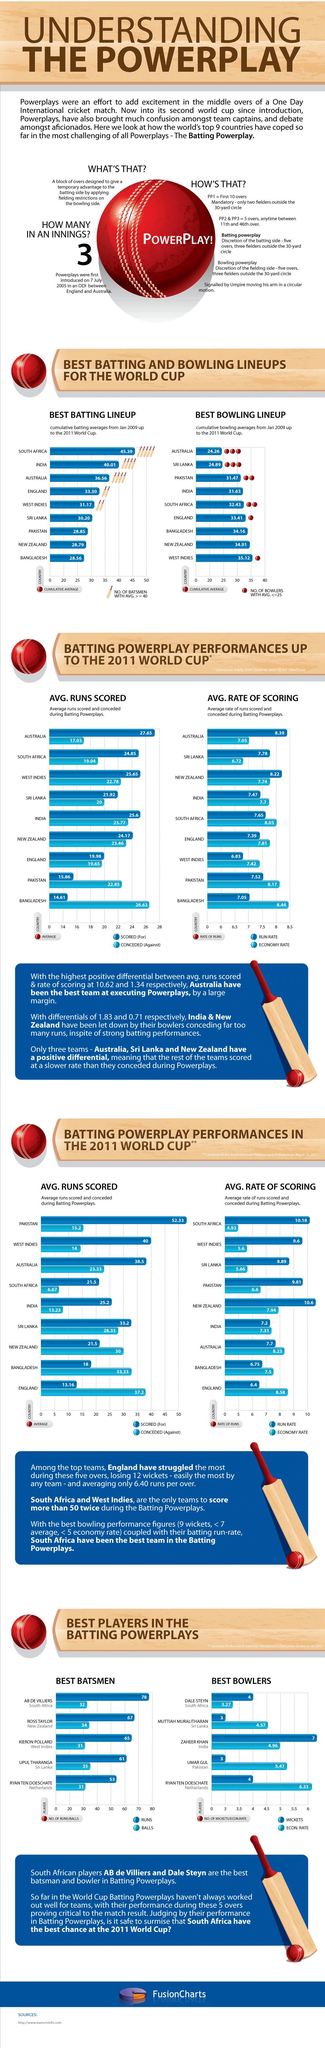Highlight a few significant elements in this photo. New Zealand has the second-lowest bowling lineup among all countries. New Zealand has the second-lowest batting lineup among all countries. India has the second-highest batting lineups, as compared to other countries. Sri Lanka has the second-highest bowling lineups in the world. 